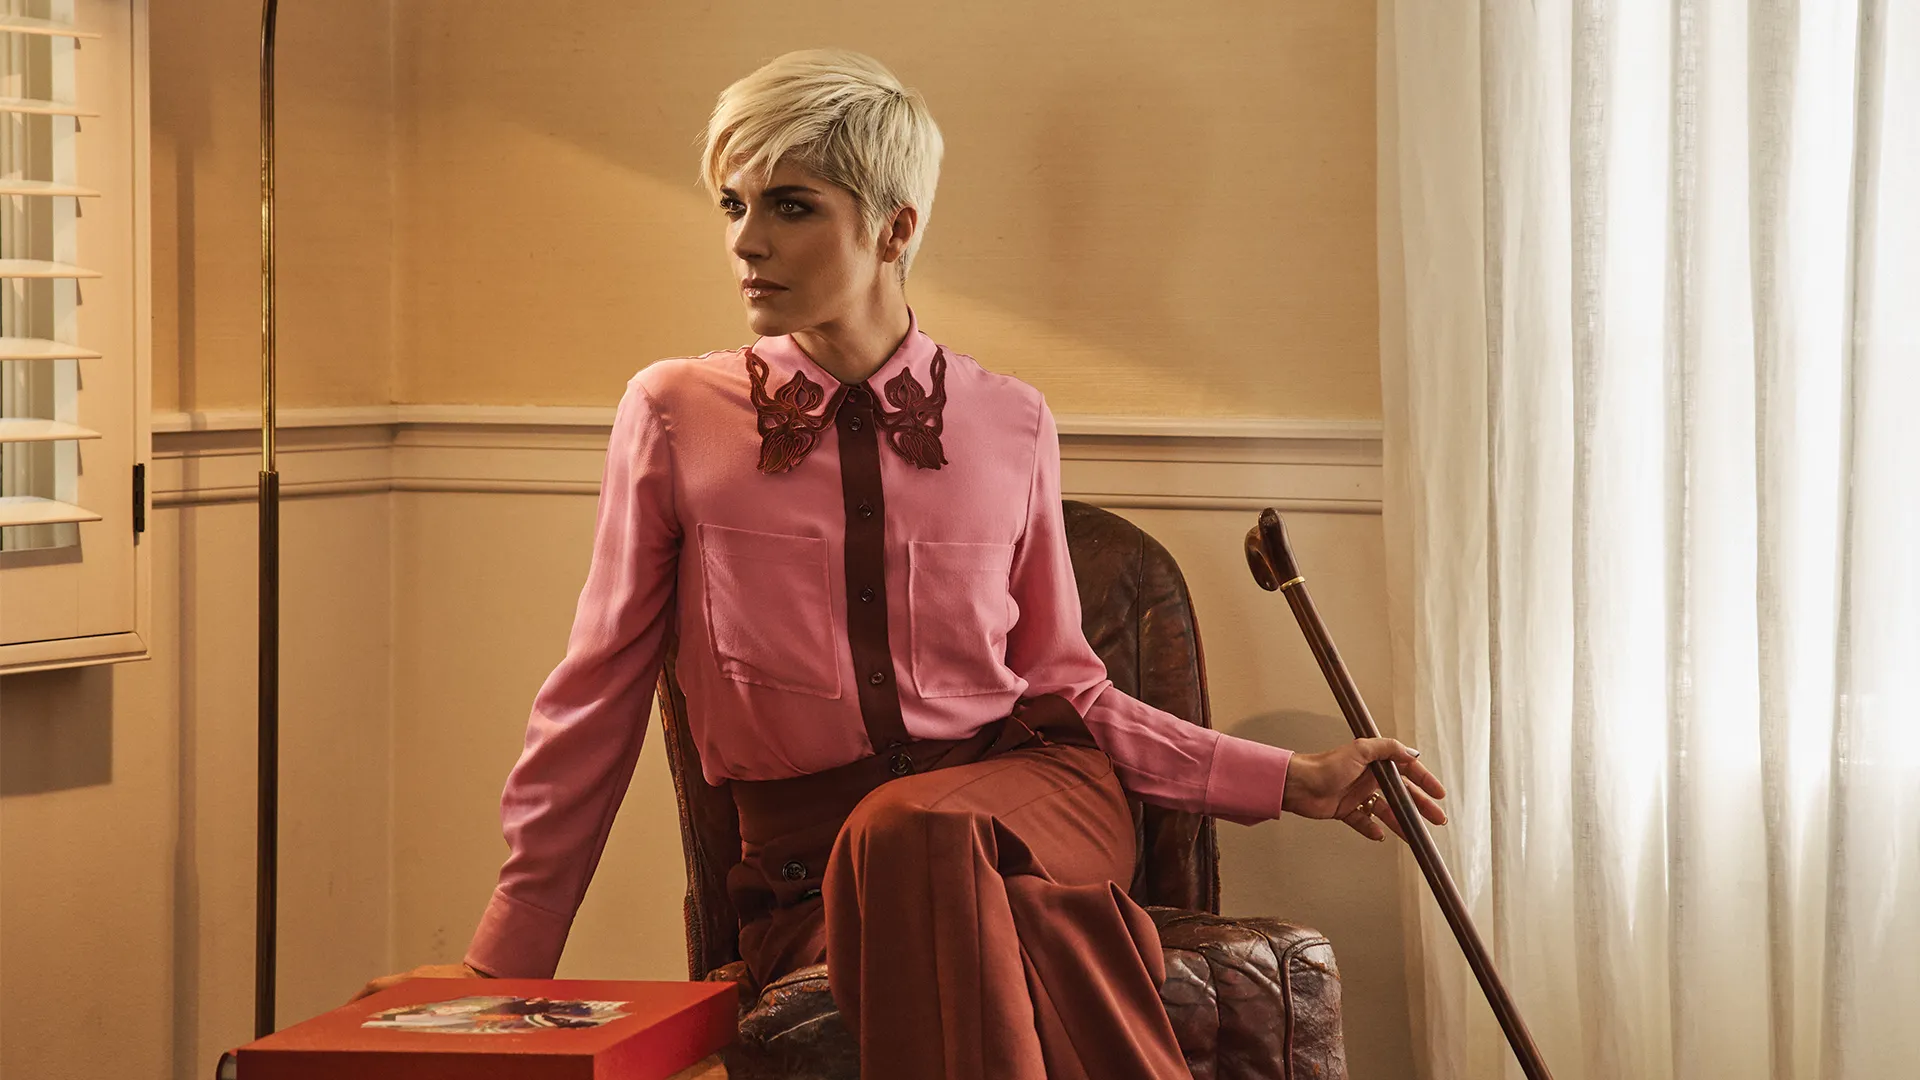What do you see happening in this image? In this image, a woman appears to be in a moment of deep reflection. She is seated in a brown leather armchair and dressed in an elegant outfit consisting of a pink blouse with an intricate butterfly collar and maroon trousers. Her short blonde hair is styled in a chic pixie cut. Holding a cane in her right hand, she exudes an aura of strength and resilience. On her lap rests a red box with unknown contents, adding an element of mystery. The backdrop features a beige wall and white curtains, which provide a neutral canvas that highlights her presence and contemplative demeanor. 